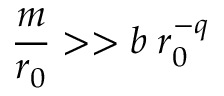<formula> <loc_0><loc_0><loc_500><loc_500>\frac { m } { r _ { 0 } } > > b \, r _ { 0 } ^ { - q }</formula> 